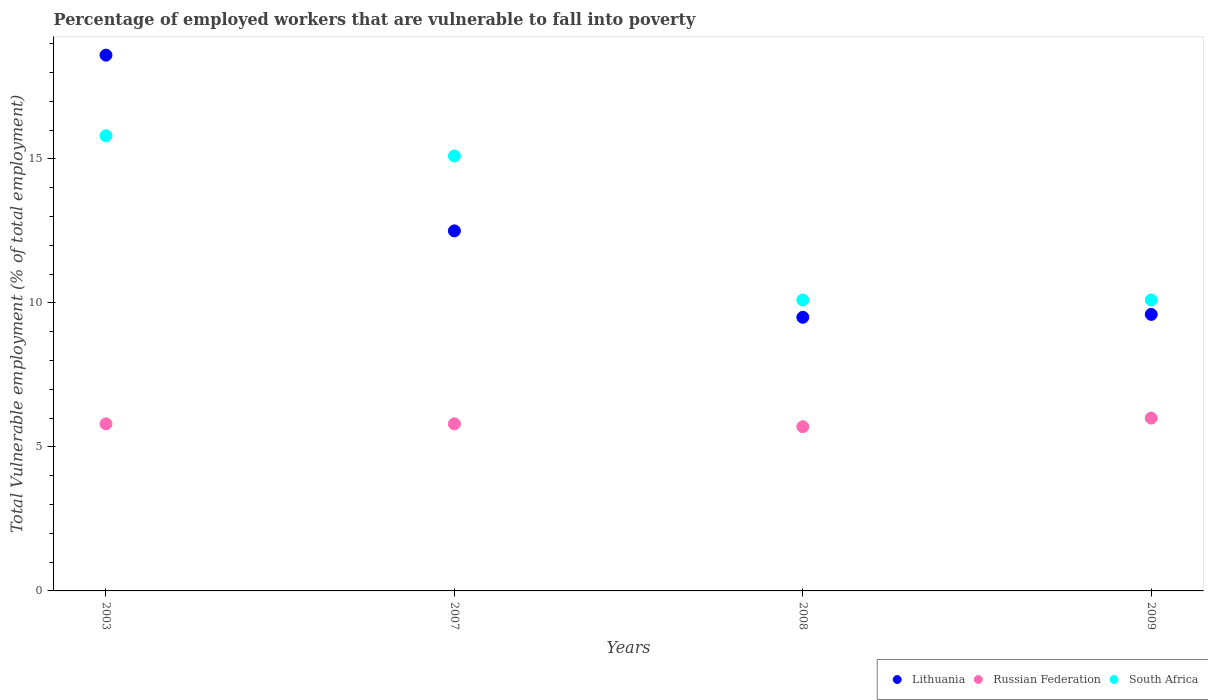Is the number of dotlines equal to the number of legend labels?
Make the answer very short. Yes. What is the percentage of employed workers who are vulnerable to fall into poverty in Russian Federation in 2003?
Keep it short and to the point. 5.8. Across all years, what is the maximum percentage of employed workers who are vulnerable to fall into poverty in South Africa?
Make the answer very short. 15.8. Across all years, what is the minimum percentage of employed workers who are vulnerable to fall into poverty in South Africa?
Provide a succinct answer. 10.1. In which year was the percentage of employed workers who are vulnerable to fall into poverty in Lithuania maximum?
Your response must be concise. 2003. What is the total percentage of employed workers who are vulnerable to fall into poverty in Lithuania in the graph?
Offer a terse response. 50.2. What is the difference between the percentage of employed workers who are vulnerable to fall into poverty in Lithuania in 2009 and the percentage of employed workers who are vulnerable to fall into poverty in Russian Federation in 2008?
Your answer should be very brief. 3.9. What is the average percentage of employed workers who are vulnerable to fall into poverty in Lithuania per year?
Your response must be concise. 12.55. In the year 2003, what is the difference between the percentage of employed workers who are vulnerable to fall into poverty in South Africa and percentage of employed workers who are vulnerable to fall into poverty in Lithuania?
Your answer should be compact. -2.8. What is the ratio of the percentage of employed workers who are vulnerable to fall into poverty in South Africa in 2003 to that in 2008?
Provide a short and direct response. 1.56. What is the difference between the highest and the second highest percentage of employed workers who are vulnerable to fall into poverty in South Africa?
Keep it short and to the point. 0.7. What is the difference between the highest and the lowest percentage of employed workers who are vulnerable to fall into poverty in South Africa?
Offer a very short reply. 5.7. In how many years, is the percentage of employed workers who are vulnerable to fall into poverty in Russian Federation greater than the average percentage of employed workers who are vulnerable to fall into poverty in Russian Federation taken over all years?
Your answer should be compact. 1. Is it the case that in every year, the sum of the percentage of employed workers who are vulnerable to fall into poverty in South Africa and percentage of employed workers who are vulnerable to fall into poverty in Lithuania  is greater than the percentage of employed workers who are vulnerable to fall into poverty in Russian Federation?
Keep it short and to the point. Yes. Is the percentage of employed workers who are vulnerable to fall into poverty in Russian Federation strictly greater than the percentage of employed workers who are vulnerable to fall into poverty in South Africa over the years?
Provide a short and direct response. No. How many dotlines are there?
Provide a succinct answer. 3. What is the difference between two consecutive major ticks on the Y-axis?
Keep it short and to the point. 5. Does the graph contain any zero values?
Make the answer very short. No. How many legend labels are there?
Provide a succinct answer. 3. How are the legend labels stacked?
Offer a terse response. Horizontal. What is the title of the graph?
Give a very brief answer. Percentage of employed workers that are vulnerable to fall into poverty. What is the label or title of the Y-axis?
Your answer should be compact. Total Vulnerable employment (% of total employment). What is the Total Vulnerable employment (% of total employment) in Lithuania in 2003?
Offer a very short reply. 18.6. What is the Total Vulnerable employment (% of total employment) of Russian Federation in 2003?
Your response must be concise. 5.8. What is the Total Vulnerable employment (% of total employment) of South Africa in 2003?
Give a very brief answer. 15.8. What is the Total Vulnerable employment (% of total employment) in Lithuania in 2007?
Your response must be concise. 12.5. What is the Total Vulnerable employment (% of total employment) in Russian Federation in 2007?
Keep it short and to the point. 5.8. What is the Total Vulnerable employment (% of total employment) in South Africa in 2007?
Make the answer very short. 15.1. What is the Total Vulnerable employment (% of total employment) of Russian Federation in 2008?
Your response must be concise. 5.7. What is the Total Vulnerable employment (% of total employment) in South Africa in 2008?
Offer a terse response. 10.1. What is the Total Vulnerable employment (% of total employment) in Lithuania in 2009?
Your answer should be compact. 9.6. What is the Total Vulnerable employment (% of total employment) of South Africa in 2009?
Ensure brevity in your answer.  10.1. Across all years, what is the maximum Total Vulnerable employment (% of total employment) in Lithuania?
Your answer should be compact. 18.6. Across all years, what is the maximum Total Vulnerable employment (% of total employment) of South Africa?
Provide a succinct answer. 15.8. Across all years, what is the minimum Total Vulnerable employment (% of total employment) of Lithuania?
Give a very brief answer. 9.5. Across all years, what is the minimum Total Vulnerable employment (% of total employment) in Russian Federation?
Provide a short and direct response. 5.7. Across all years, what is the minimum Total Vulnerable employment (% of total employment) in South Africa?
Keep it short and to the point. 10.1. What is the total Total Vulnerable employment (% of total employment) of Lithuania in the graph?
Offer a very short reply. 50.2. What is the total Total Vulnerable employment (% of total employment) in Russian Federation in the graph?
Keep it short and to the point. 23.3. What is the total Total Vulnerable employment (% of total employment) in South Africa in the graph?
Offer a terse response. 51.1. What is the difference between the Total Vulnerable employment (% of total employment) in Lithuania in 2003 and that in 2007?
Provide a short and direct response. 6.1. What is the difference between the Total Vulnerable employment (% of total employment) of Russian Federation in 2003 and that in 2007?
Offer a terse response. 0. What is the difference between the Total Vulnerable employment (% of total employment) of South Africa in 2003 and that in 2007?
Keep it short and to the point. 0.7. What is the difference between the Total Vulnerable employment (% of total employment) of Lithuania in 2003 and that in 2009?
Ensure brevity in your answer.  9. What is the difference between the Total Vulnerable employment (% of total employment) of South Africa in 2003 and that in 2009?
Offer a very short reply. 5.7. What is the difference between the Total Vulnerable employment (% of total employment) in Russian Federation in 2007 and that in 2008?
Keep it short and to the point. 0.1. What is the difference between the Total Vulnerable employment (% of total employment) of Lithuania in 2007 and that in 2009?
Provide a succinct answer. 2.9. What is the difference between the Total Vulnerable employment (% of total employment) in Russian Federation in 2007 and that in 2009?
Your answer should be very brief. -0.2. What is the difference between the Total Vulnerable employment (% of total employment) of South Africa in 2008 and that in 2009?
Provide a short and direct response. 0. What is the difference between the Total Vulnerable employment (% of total employment) in Lithuania in 2003 and the Total Vulnerable employment (% of total employment) in Russian Federation in 2007?
Keep it short and to the point. 12.8. What is the difference between the Total Vulnerable employment (% of total employment) in Lithuania in 2003 and the Total Vulnerable employment (% of total employment) in South Africa in 2007?
Provide a short and direct response. 3.5. What is the difference between the Total Vulnerable employment (% of total employment) in Russian Federation in 2003 and the Total Vulnerable employment (% of total employment) in South Africa in 2007?
Ensure brevity in your answer.  -9.3. What is the difference between the Total Vulnerable employment (% of total employment) of Lithuania in 2003 and the Total Vulnerable employment (% of total employment) of Russian Federation in 2008?
Give a very brief answer. 12.9. What is the difference between the Total Vulnerable employment (% of total employment) of Lithuania in 2003 and the Total Vulnerable employment (% of total employment) of South Africa in 2009?
Make the answer very short. 8.5. What is the difference between the Total Vulnerable employment (% of total employment) of Russian Federation in 2003 and the Total Vulnerable employment (% of total employment) of South Africa in 2009?
Keep it short and to the point. -4.3. What is the difference between the Total Vulnerable employment (% of total employment) of Lithuania in 2007 and the Total Vulnerable employment (% of total employment) of Russian Federation in 2008?
Ensure brevity in your answer.  6.8. What is the difference between the Total Vulnerable employment (% of total employment) in Russian Federation in 2007 and the Total Vulnerable employment (% of total employment) in South Africa in 2008?
Provide a succinct answer. -4.3. What is the difference between the Total Vulnerable employment (% of total employment) in Lithuania in 2007 and the Total Vulnerable employment (% of total employment) in Russian Federation in 2009?
Ensure brevity in your answer.  6.5. What is the difference between the Total Vulnerable employment (% of total employment) in Lithuania in 2007 and the Total Vulnerable employment (% of total employment) in South Africa in 2009?
Your response must be concise. 2.4. What is the average Total Vulnerable employment (% of total employment) of Lithuania per year?
Offer a very short reply. 12.55. What is the average Total Vulnerable employment (% of total employment) of Russian Federation per year?
Keep it short and to the point. 5.83. What is the average Total Vulnerable employment (% of total employment) of South Africa per year?
Make the answer very short. 12.78. In the year 2003, what is the difference between the Total Vulnerable employment (% of total employment) of Lithuania and Total Vulnerable employment (% of total employment) of South Africa?
Your answer should be compact. 2.8. In the year 2003, what is the difference between the Total Vulnerable employment (% of total employment) of Russian Federation and Total Vulnerable employment (% of total employment) of South Africa?
Ensure brevity in your answer.  -10. In the year 2007, what is the difference between the Total Vulnerable employment (% of total employment) in Lithuania and Total Vulnerable employment (% of total employment) in Russian Federation?
Provide a short and direct response. 6.7. In the year 2007, what is the difference between the Total Vulnerable employment (% of total employment) in Lithuania and Total Vulnerable employment (% of total employment) in South Africa?
Your answer should be very brief. -2.6. In the year 2008, what is the difference between the Total Vulnerable employment (% of total employment) in Lithuania and Total Vulnerable employment (% of total employment) in South Africa?
Offer a very short reply. -0.6. In the year 2009, what is the difference between the Total Vulnerable employment (% of total employment) in Lithuania and Total Vulnerable employment (% of total employment) in Russian Federation?
Ensure brevity in your answer.  3.6. What is the ratio of the Total Vulnerable employment (% of total employment) of Lithuania in 2003 to that in 2007?
Your answer should be very brief. 1.49. What is the ratio of the Total Vulnerable employment (% of total employment) in South Africa in 2003 to that in 2007?
Make the answer very short. 1.05. What is the ratio of the Total Vulnerable employment (% of total employment) of Lithuania in 2003 to that in 2008?
Your answer should be very brief. 1.96. What is the ratio of the Total Vulnerable employment (% of total employment) of Russian Federation in 2003 to that in 2008?
Your answer should be compact. 1.02. What is the ratio of the Total Vulnerable employment (% of total employment) of South Africa in 2003 to that in 2008?
Give a very brief answer. 1.56. What is the ratio of the Total Vulnerable employment (% of total employment) in Lithuania in 2003 to that in 2009?
Provide a succinct answer. 1.94. What is the ratio of the Total Vulnerable employment (% of total employment) of Russian Federation in 2003 to that in 2009?
Keep it short and to the point. 0.97. What is the ratio of the Total Vulnerable employment (% of total employment) in South Africa in 2003 to that in 2009?
Give a very brief answer. 1.56. What is the ratio of the Total Vulnerable employment (% of total employment) in Lithuania in 2007 to that in 2008?
Provide a short and direct response. 1.32. What is the ratio of the Total Vulnerable employment (% of total employment) of Russian Federation in 2007 to that in 2008?
Your answer should be compact. 1.02. What is the ratio of the Total Vulnerable employment (% of total employment) of South Africa in 2007 to that in 2008?
Your answer should be compact. 1.5. What is the ratio of the Total Vulnerable employment (% of total employment) in Lithuania in 2007 to that in 2009?
Offer a very short reply. 1.3. What is the ratio of the Total Vulnerable employment (% of total employment) in Russian Federation in 2007 to that in 2009?
Your response must be concise. 0.97. What is the ratio of the Total Vulnerable employment (% of total employment) of South Africa in 2007 to that in 2009?
Your answer should be compact. 1.5. What is the ratio of the Total Vulnerable employment (% of total employment) of Lithuania in 2008 to that in 2009?
Your answer should be compact. 0.99. What is the ratio of the Total Vulnerable employment (% of total employment) in South Africa in 2008 to that in 2009?
Give a very brief answer. 1. What is the difference between the highest and the second highest Total Vulnerable employment (% of total employment) in Lithuania?
Give a very brief answer. 6.1. What is the difference between the highest and the second highest Total Vulnerable employment (% of total employment) in Russian Federation?
Ensure brevity in your answer.  0.2. What is the difference between the highest and the lowest Total Vulnerable employment (% of total employment) in South Africa?
Your answer should be compact. 5.7. 